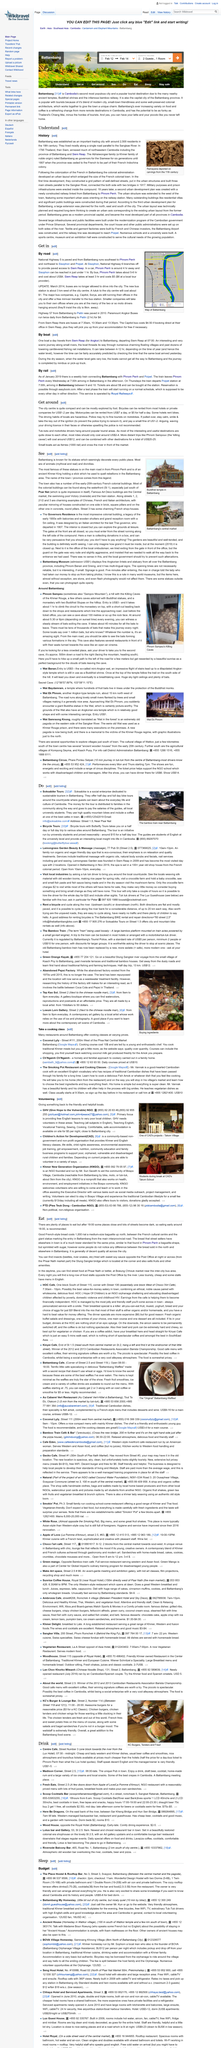Give some essential details in this illustration. There are several options for booking a half day or full day bike tour around Battambang. Soksabike Tours and Bicycle Tours are two reputable companies that offer scenic routes and guided tours of the city and surrounding areas. These tours are a great way to experience the local culture and natural beauty of Battambang. It is recommended to eat dinner at 6:00 PM. Battambang, a city in Cambodia, is located in which country? It is expected that volunteers will pay $5 per night for accommodation while participating in the Give Hope to the Vulnerable program. Motorbike drivers are frequently found in popular tourist destinations. 